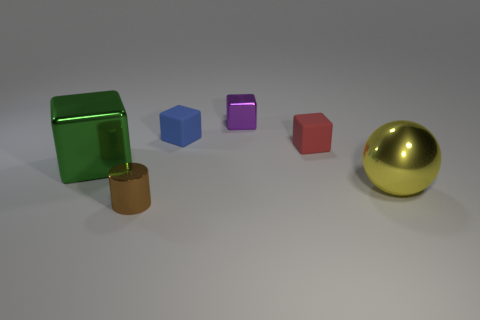Subtract all small blocks. How many blocks are left? 1 Subtract all red cubes. How many cubes are left? 3 Subtract all blue blocks. Subtract all yellow balls. How many blocks are left? 3 Add 4 large brown matte cylinders. How many objects exist? 10 Subtract all blocks. How many objects are left? 2 Subtract all tiny cyan shiny blocks. Subtract all small brown shiny cylinders. How many objects are left? 5 Add 1 small purple blocks. How many small purple blocks are left? 2 Add 1 red matte objects. How many red matte objects exist? 2 Subtract 0 red cylinders. How many objects are left? 6 